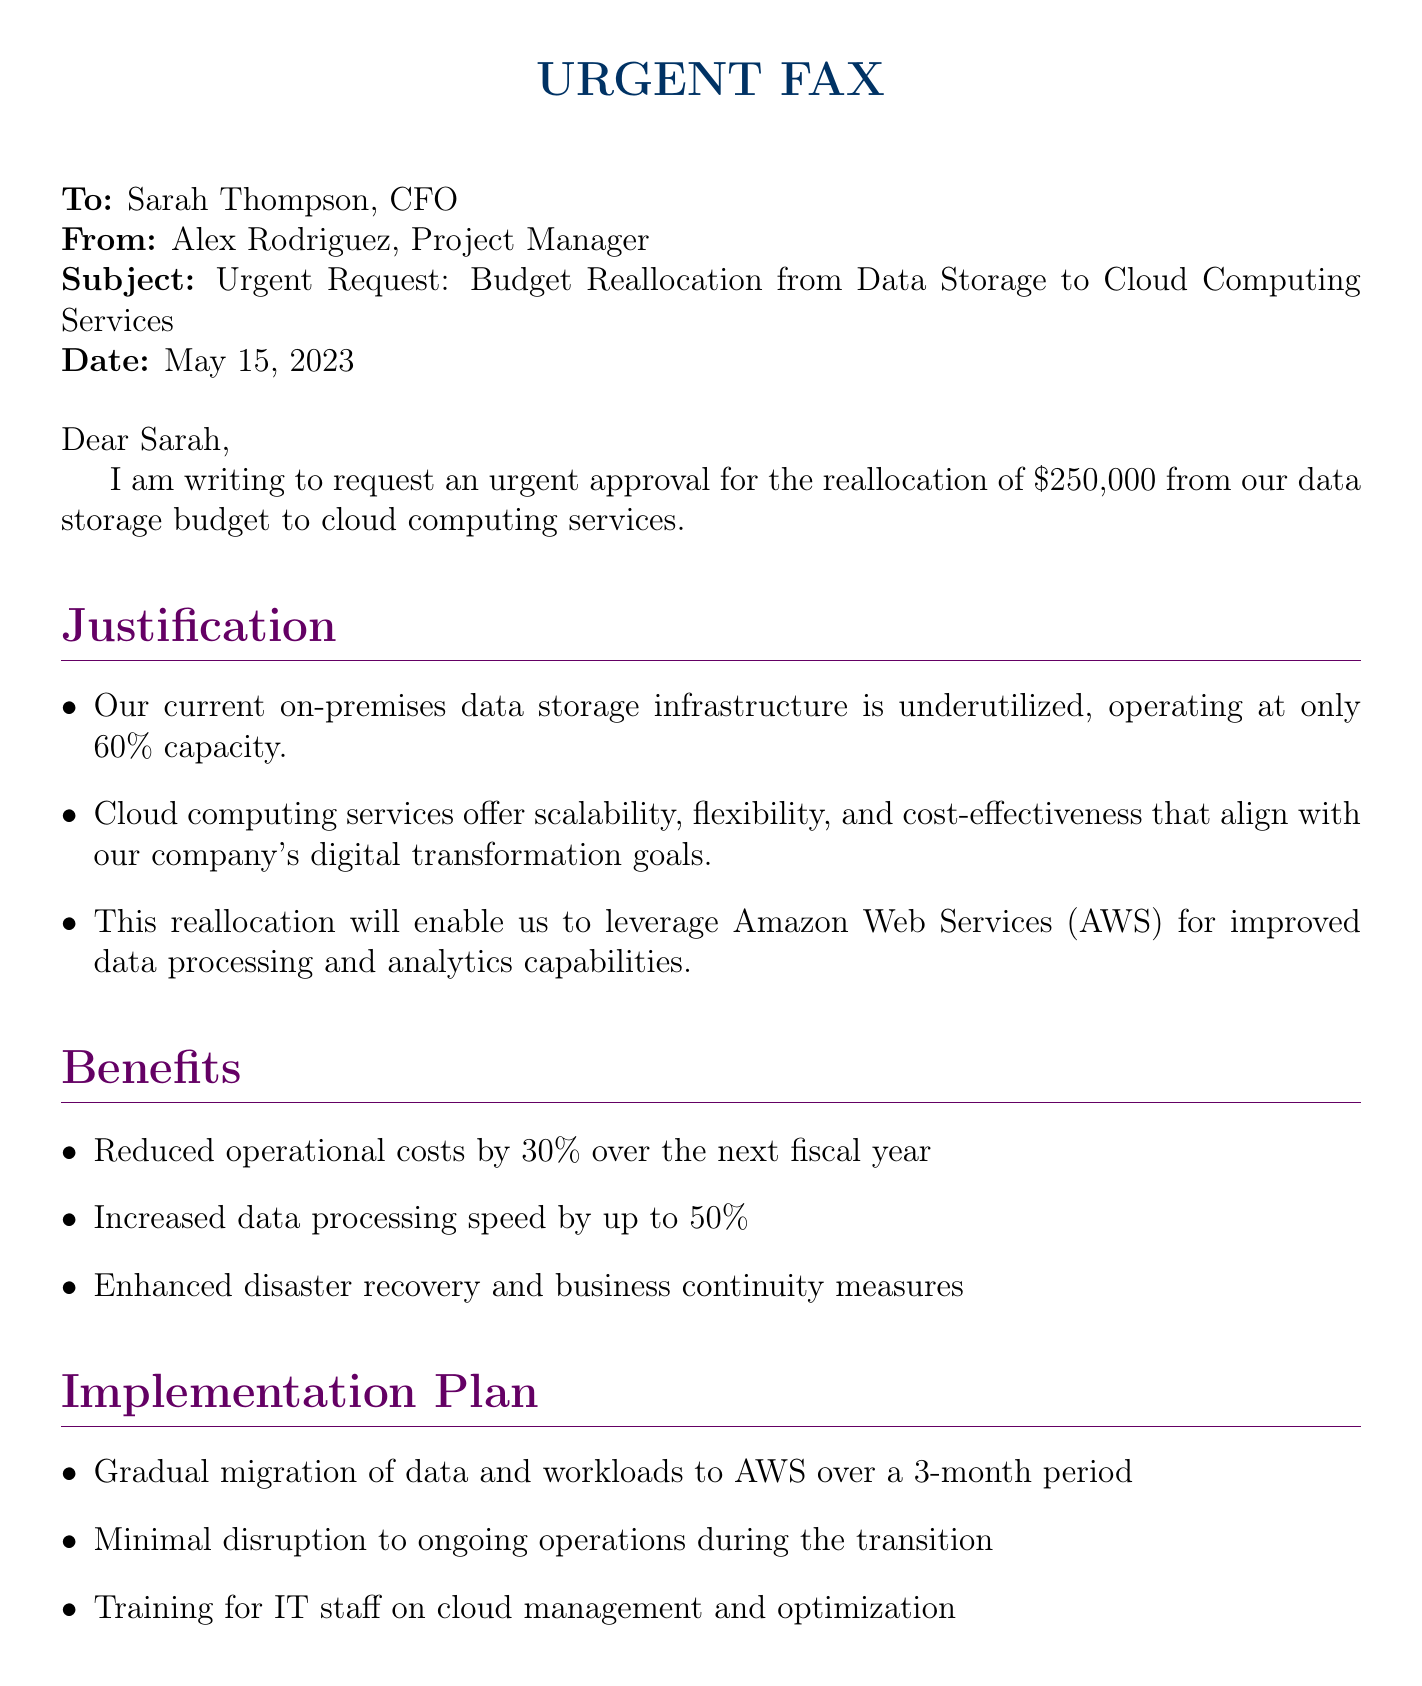What is the date of the fax? The date mentioned in the fax is May 15, 2023.
Answer: May 15, 2023 Who is the sender of the fax? The sender of the fax is Alex Rodriguez, a Project Manager.
Answer: Alex Rodriguez What is the amount requested for reallocation? The requested amount for the reallocation from data storage is $250,000.
Answer: $250,000 What percentage of operational cost reduction is anticipated? The fax mentions a reduced operational cost by 30% over the next fiscal year.
Answer: 30% What is the current data storage budget? The current data storage budget listed in the fax is $750,000.
Answer: $750,000 What is the proposed new cloud computing budget? The proposed new budget for cloud computing is $250,000.
Answer: $250,000 How long is the gradual migration planned to take? The gradual migration of data and workloads to AWS is planned to take 3 months.
Answer: 3 months What is the primary cloud service mentioned in the fax? The primary cloud service referenced is Amazon Web Services (AWS).
Answer: Amazon Web Services What is the main focus of the fax? The main focus of the fax is to request budget reallocation to enhance data infrastructure.
Answer: Budget reallocation to enhance data infrastructure 